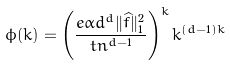<formula> <loc_0><loc_0><loc_500><loc_500>\phi ( k ) = \left ( \frac { e \alpha d ^ { d } \| \widehat { f } \| _ { 1 } ^ { 2 } } { t n ^ { d - 1 } } \right ) ^ { k } k ^ { ( d - 1 ) k }</formula> 